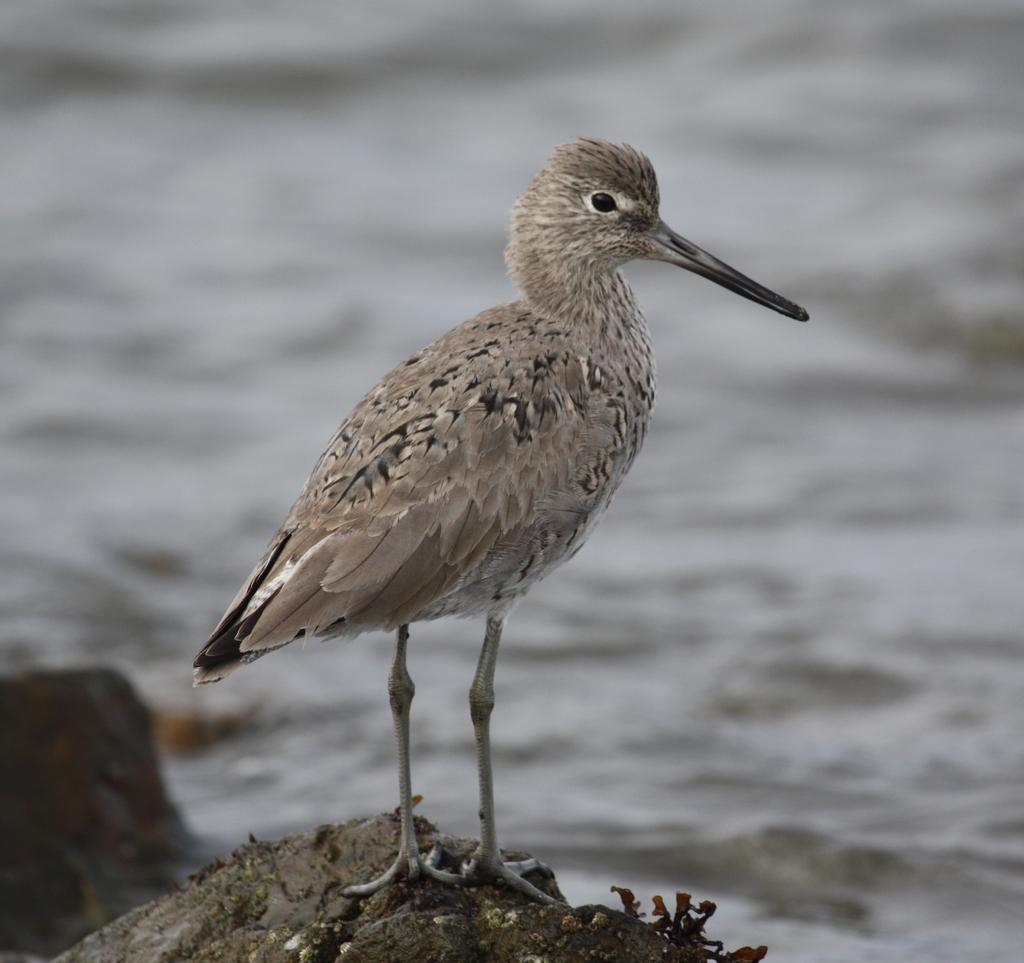What type of animal can be seen in the image? There is a bird in the image. What other object is present in the image? There is a rock in the image. What type of army is depicted in the image? There is no army present in the image; it only features a bird and a rock. How many stars can be seen in the image? There are no stars visible in the image. 